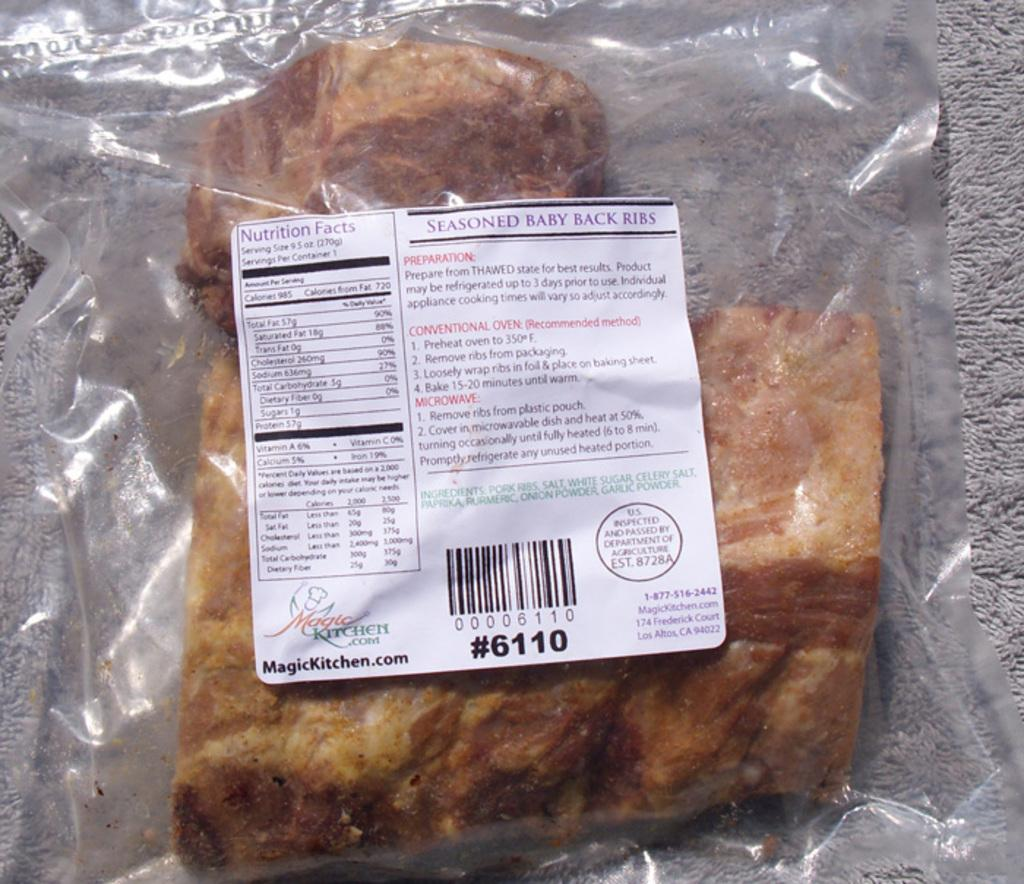What is the main subject of the image? There is a food item in the image. How is the food item packaged? The food item is packed in a plastic cover. Is there any additional information or labeling on the packaging? Yes, there is a sticker on the plastic cover. What type of lace can be seen on the food item in the image? There is no lace present on the food item in the image. Can you tell me how many insects are crawling on the sticker in the image? There are no insects present on the sticker or anywhere in the image. 